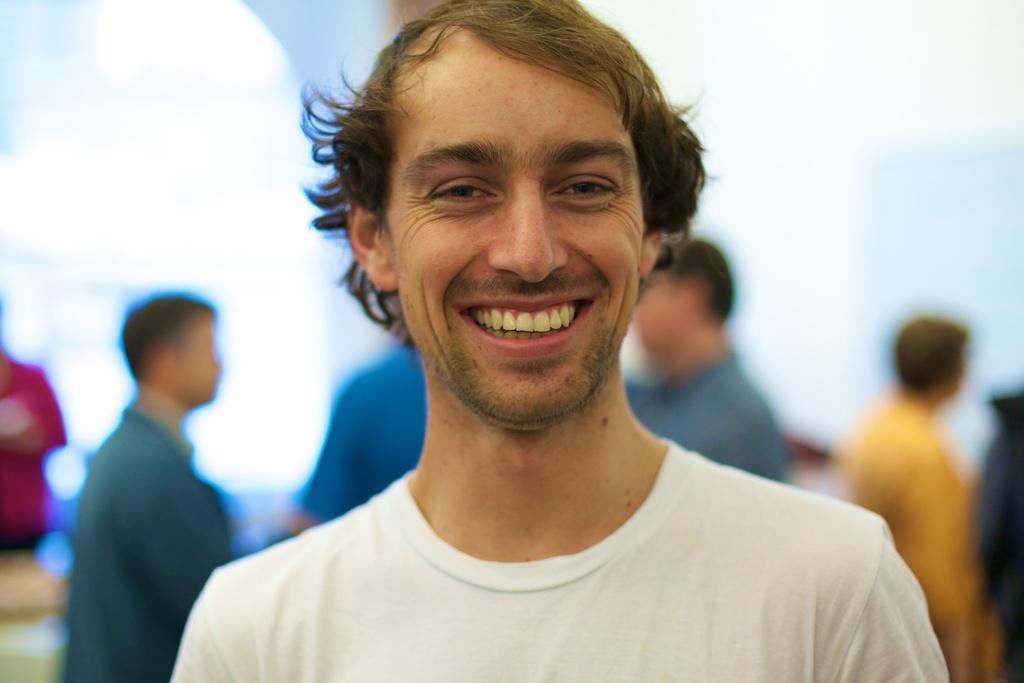How would you summarize this image in a sentence or two? In this picture we can observe a person smiling. He is wearing white color T shirt. In the background there are some persons standing. 